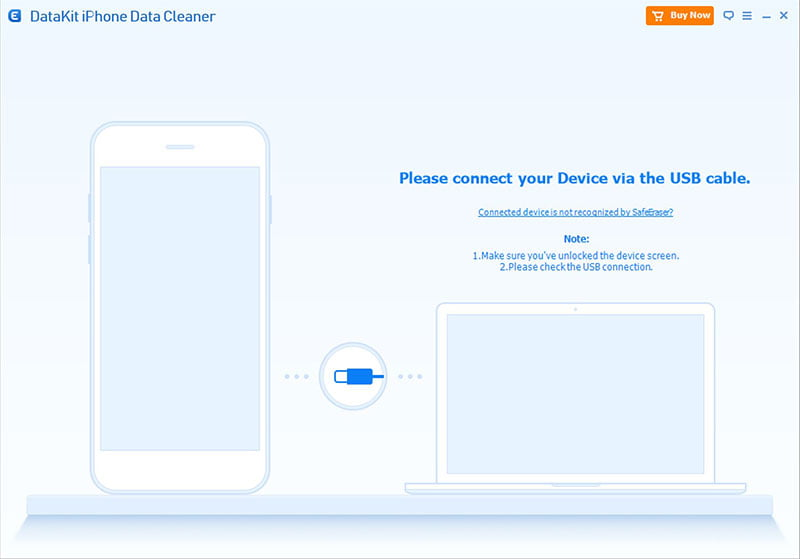In a realistic scenario, describe how a business professional might use this software during their busy workday. A business professional might use this software during a busy workday to ensure their iPhone data stays organized and secure. For instance, amid back-to-back meetings, they may quickly connect their iPhone to their laptop using the USB cable depicted. Being on a tight schedule, they rely on the software's automated features to cleaned unneeded files, ensuring their device operates smoothly, readying for an important virtual conference call. The user appreciates the efficiency of troubleshooting tips, like confirming the device is unlocked and checking the USB connection, as they can swiftly resolve any issues and continue their productivity without a hitch. Throughout the day, the professional may also use the software to back up essential data or prepare the device for a presentation, showcasing their organized approach to technology management. 
Quick scenario: Why might a student find this software useful? A student might find this software useful for maintaining their iPhone storage clutter-free, especially when they need to free up space for educational apps, projects, or media files. The troubleshooting tips provided ensure they can quickly resolve any connection issues, reducing downtime and keeping their learning resources accessible and organized. 